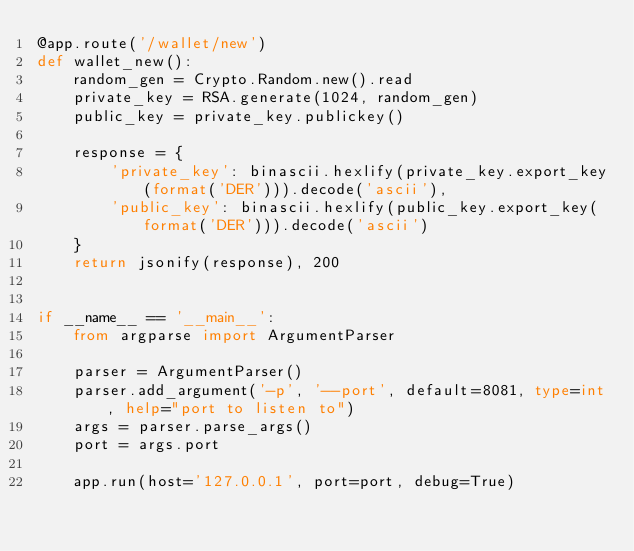Convert code to text. <code><loc_0><loc_0><loc_500><loc_500><_Python_>@app.route('/wallet/new')
def wallet_new():
    random_gen = Crypto.Random.new().read
    private_key = RSA.generate(1024, random_gen)
    public_key = private_key.publickey()

    response = {
        'private_key': binascii.hexlify(private_key.export_key(format('DER'))).decode('ascii'),
        'public_key': binascii.hexlify(public_key.export_key(format('DER'))).decode('ascii')
    }
    return jsonify(response), 200


if __name__ == '__main__':
    from argparse import ArgumentParser

    parser = ArgumentParser()
    parser.add_argument('-p', '--port', default=8081, type=int, help="port to listen to")
    args = parser.parse_args()
    port = args.port

    app.run(host='127.0.0.1', port=port, debug=True)
</code> 